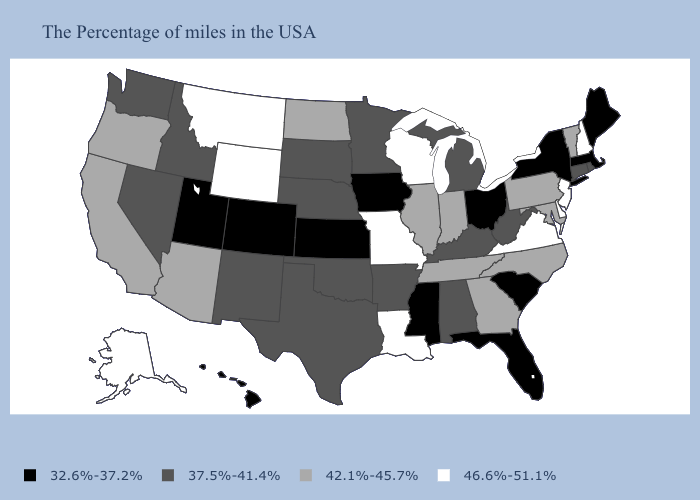Among the states that border New Jersey , which have the highest value?
Concise answer only. Delaware. What is the lowest value in the Northeast?
Be succinct. 32.6%-37.2%. Among the states that border Wyoming , does Colorado have the highest value?
Short answer required. No. Does the map have missing data?
Write a very short answer. No. Name the states that have a value in the range 37.5%-41.4%?
Keep it brief. Rhode Island, Connecticut, West Virginia, Michigan, Kentucky, Alabama, Arkansas, Minnesota, Nebraska, Oklahoma, Texas, South Dakota, New Mexico, Idaho, Nevada, Washington. What is the lowest value in states that border Ohio?
Write a very short answer. 37.5%-41.4%. What is the lowest value in the Northeast?
Give a very brief answer. 32.6%-37.2%. Name the states that have a value in the range 37.5%-41.4%?
Concise answer only. Rhode Island, Connecticut, West Virginia, Michigan, Kentucky, Alabama, Arkansas, Minnesota, Nebraska, Oklahoma, Texas, South Dakota, New Mexico, Idaho, Nevada, Washington. What is the lowest value in the Northeast?
Give a very brief answer. 32.6%-37.2%. Does the map have missing data?
Quick response, please. No. Among the states that border Connecticut , which have the highest value?
Concise answer only. Rhode Island. Does the map have missing data?
Give a very brief answer. No. What is the value of Alabama?
Be succinct. 37.5%-41.4%. What is the highest value in the USA?
Concise answer only. 46.6%-51.1%. 